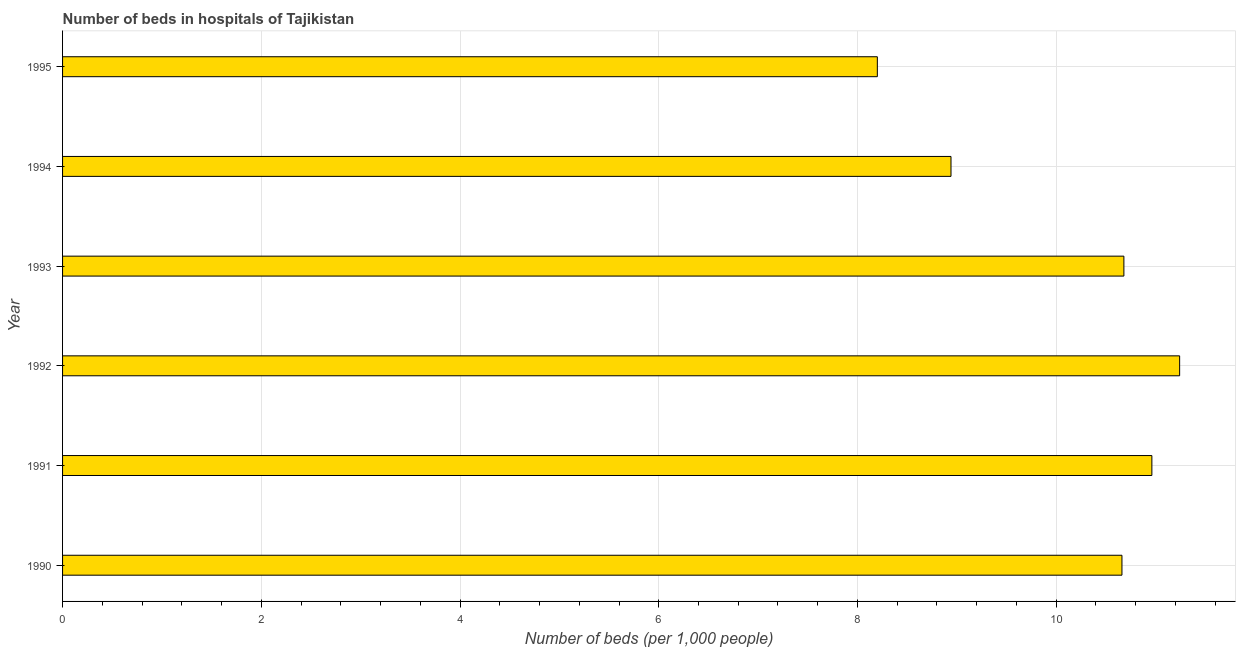Does the graph contain any zero values?
Give a very brief answer. No. What is the title of the graph?
Your response must be concise. Number of beds in hospitals of Tajikistan. What is the label or title of the X-axis?
Offer a terse response. Number of beds (per 1,0 people). What is the number of hospital beds in 1990?
Your answer should be very brief. 10.66. Across all years, what is the maximum number of hospital beds?
Your response must be concise. 11.24. Across all years, what is the minimum number of hospital beds?
Offer a very short reply. 8.2. In which year was the number of hospital beds minimum?
Provide a succinct answer. 1995. What is the sum of the number of hospital beds?
Offer a very short reply. 60.69. What is the difference between the number of hospital beds in 1990 and 1995?
Your response must be concise. 2.46. What is the average number of hospital beds per year?
Ensure brevity in your answer.  10.12. What is the median number of hospital beds?
Ensure brevity in your answer.  10.67. What is the ratio of the number of hospital beds in 1992 to that in 1994?
Offer a very short reply. 1.26. What is the difference between the highest and the second highest number of hospital beds?
Your answer should be very brief. 0.28. What is the difference between the highest and the lowest number of hospital beds?
Keep it short and to the point. 3.04. In how many years, is the number of hospital beds greater than the average number of hospital beds taken over all years?
Offer a very short reply. 4. How many bars are there?
Provide a short and direct response. 6. Are the values on the major ticks of X-axis written in scientific E-notation?
Keep it short and to the point. No. What is the Number of beds (per 1,000 people) of 1990?
Offer a terse response. 10.66. What is the Number of beds (per 1,000 people) in 1991?
Your answer should be compact. 10.96. What is the Number of beds (per 1,000 people) in 1992?
Offer a very short reply. 11.24. What is the Number of beds (per 1,000 people) in 1993?
Keep it short and to the point. 10.68. What is the Number of beds (per 1,000 people) in 1994?
Keep it short and to the point. 8.94. What is the Number of beds (per 1,000 people) of 1995?
Provide a succinct answer. 8.2. What is the difference between the Number of beds (per 1,000 people) in 1990 and 1991?
Give a very brief answer. -0.3. What is the difference between the Number of beds (per 1,000 people) in 1990 and 1992?
Ensure brevity in your answer.  -0.58. What is the difference between the Number of beds (per 1,000 people) in 1990 and 1993?
Provide a succinct answer. -0.02. What is the difference between the Number of beds (per 1,000 people) in 1990 and 1994?
Make the answer very short. 1.72. What is the difference between the Number of beds (per 1,000 people) in 1990 and 1995?
Your answer should be very brief. 2.46. What is the difference between the Number of beds (per 1,000 people) in 1991 and 1992?
Offer a very short reply. -0.28. What is the difference between the Number of beds (per 1,000 people) in 1991 and 1993?
Your answer should be very brief. 0.28. What is the difference between the Number of beds (per 1,000 people) in 1991 and 1994?
Your answer should be compact. 2.02. What is the difference between the Number of beds (per 1,000 people) in 1991 and 1995?
Make the answer very short. 2.76. What is the difference between the Number of beds (per 1,000 people) in 1992 and 1993?
Keep it short and to the point. 0.56. What is the difference between the Number of beds (per 1,000 people) in 1992 and 1994?
Keep it short and to the point. 2.3. What is the difference between the Number of beds (per 1,000 people) in 1992 and 1995?
Ensure brevity in your answer.  3.04. What is the difference between the Number of beds (per 1,000 people) in 1993 and 1994?
Your response must be concise. 1.74. What is the difference between the Number of beds (per 1,000 people) in 1993 and 1995?
Provide a short and direct response. 2.48. What is the difference between the Number of beds (per 1,000 people) in 1994 and 1995?
Provide a short and direct response. 0.74. What is the ratio of the Number of beds (per 1,000 people) in 1990 to that in 1991?
Your answer should be compact. 0.97. What is the ratio of the Number of beds (per 1,000 people) in 1990 to that in 1992?
Provide a short and direct response. 0.95. What is the ratio of the Number of beds (per 1,000 people) in 1990 to that in 1993?
Your response must be concise. 1. What is the ratio of the Number of beds (per 1,000 people) in 1990 to that in 1994?
Keep it short and to the point. 1.19. What is the ratio of the Number of beds (per 1,000 people) in 1991 to that in 1994?
Keep it short and to the point. 1.23. What is the ratio of the Number of beds (per 1,000 people) in 1991 to that in 1995?
Offer a very short reply. 1.34. What is the ratio of the Number of beds (per 1,000 people) in 1992 to that in 1993?
Provide a succinct answer. 1.05. What is the ratio of the Number of beds (per 1,000 people) in 1992 to that in 1994?
Your answer should be very brief. 1.26. What is the ratio of the Number of beds (per 1,000 people) in 1992 to that in 1995?
Offer a terse response. 1.37. What is the ratio of the Number of beds (per 1,000 people) in 1993 to that in 1994?
Offer a very short reply. 1.2. What is the ratio of the Number of beds (per 1,000 people) in 1993 to that in 1995?
Your answer should be compact. 1.3. What is the ratio of the Number of beds (per 1,000 people) in 1994 to that in 1995?
Give a very brief answer. 1.09. 